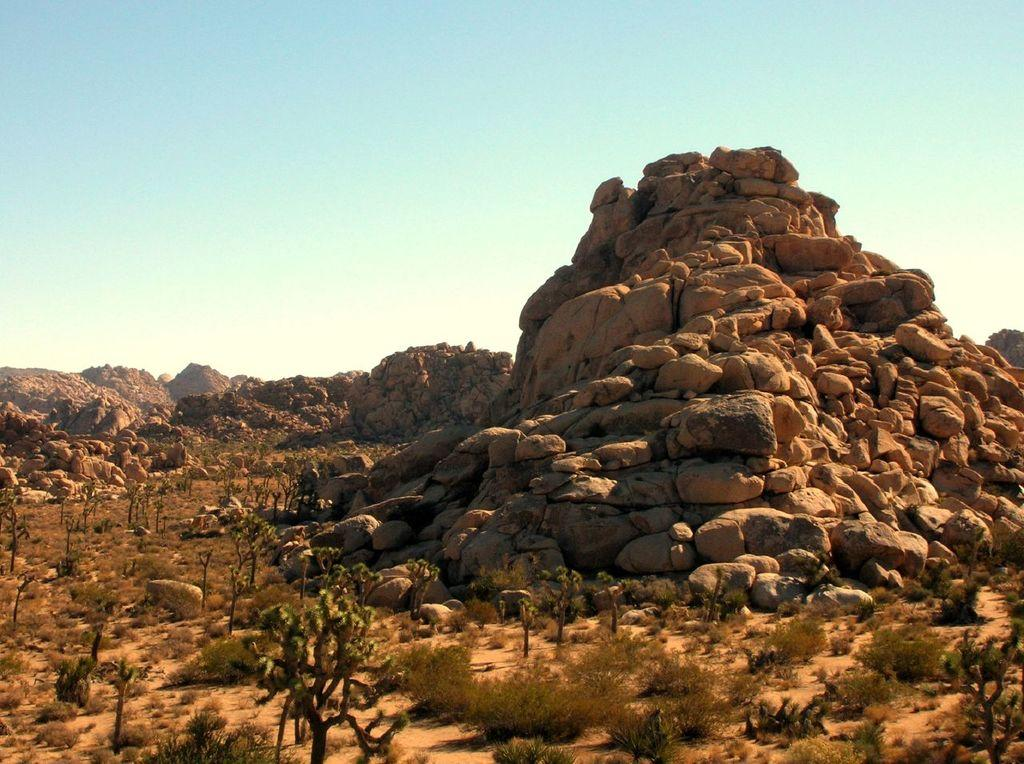What type of vegetation can be seen in the image? There are trees and plants in the image. What can be seen on the ground in the image? The ground is visible in the image. What is located in the background of the image? There is a huge mountain made up of stones, other mountains, and the sky visible in the background. How many tickets are required to enter the mouth of the mountain in the image? There is no mouth of a mountain present in the image, and therefore no tickets are required. 